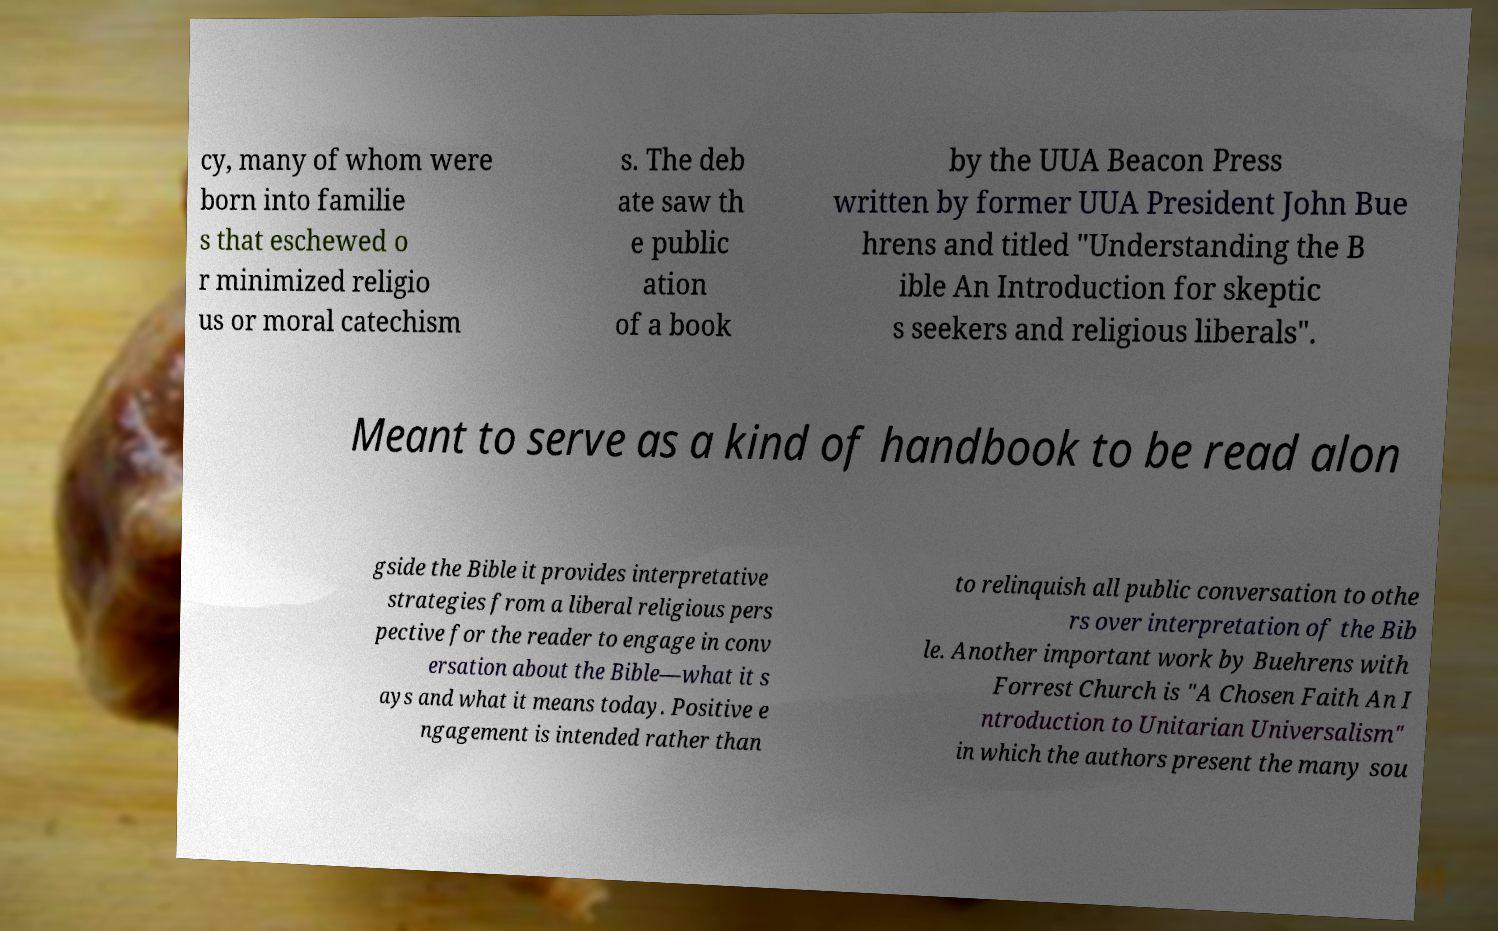Could you extract and type out the text from this image? cy, many of whom were born into familie s that eschewed o r minimized religio us or moral catechism s. The deb ate saw th e public ation of a book by the UUA Beacon Press written by former UUA President John Bue hrens and titled "Understanding the B ible An Introduction for skeptic s seekers and religious liberals". Meant to serve as a kind of handbook to be read alon gside the Bible it provides interpretative strategies from a liberal religious pers pective for the reader to engage in conv ersation about the Bible—what it s ays and what it means today. Positive e ngagement is intended rather than to relinquish all public conversation to othe rs over interpretation of the Bib le. Another important work by Buehrens with Forrest Church is "A Chosen Faith An I ntroduction to Unitarian Universalism" in which the authors present the many sou 